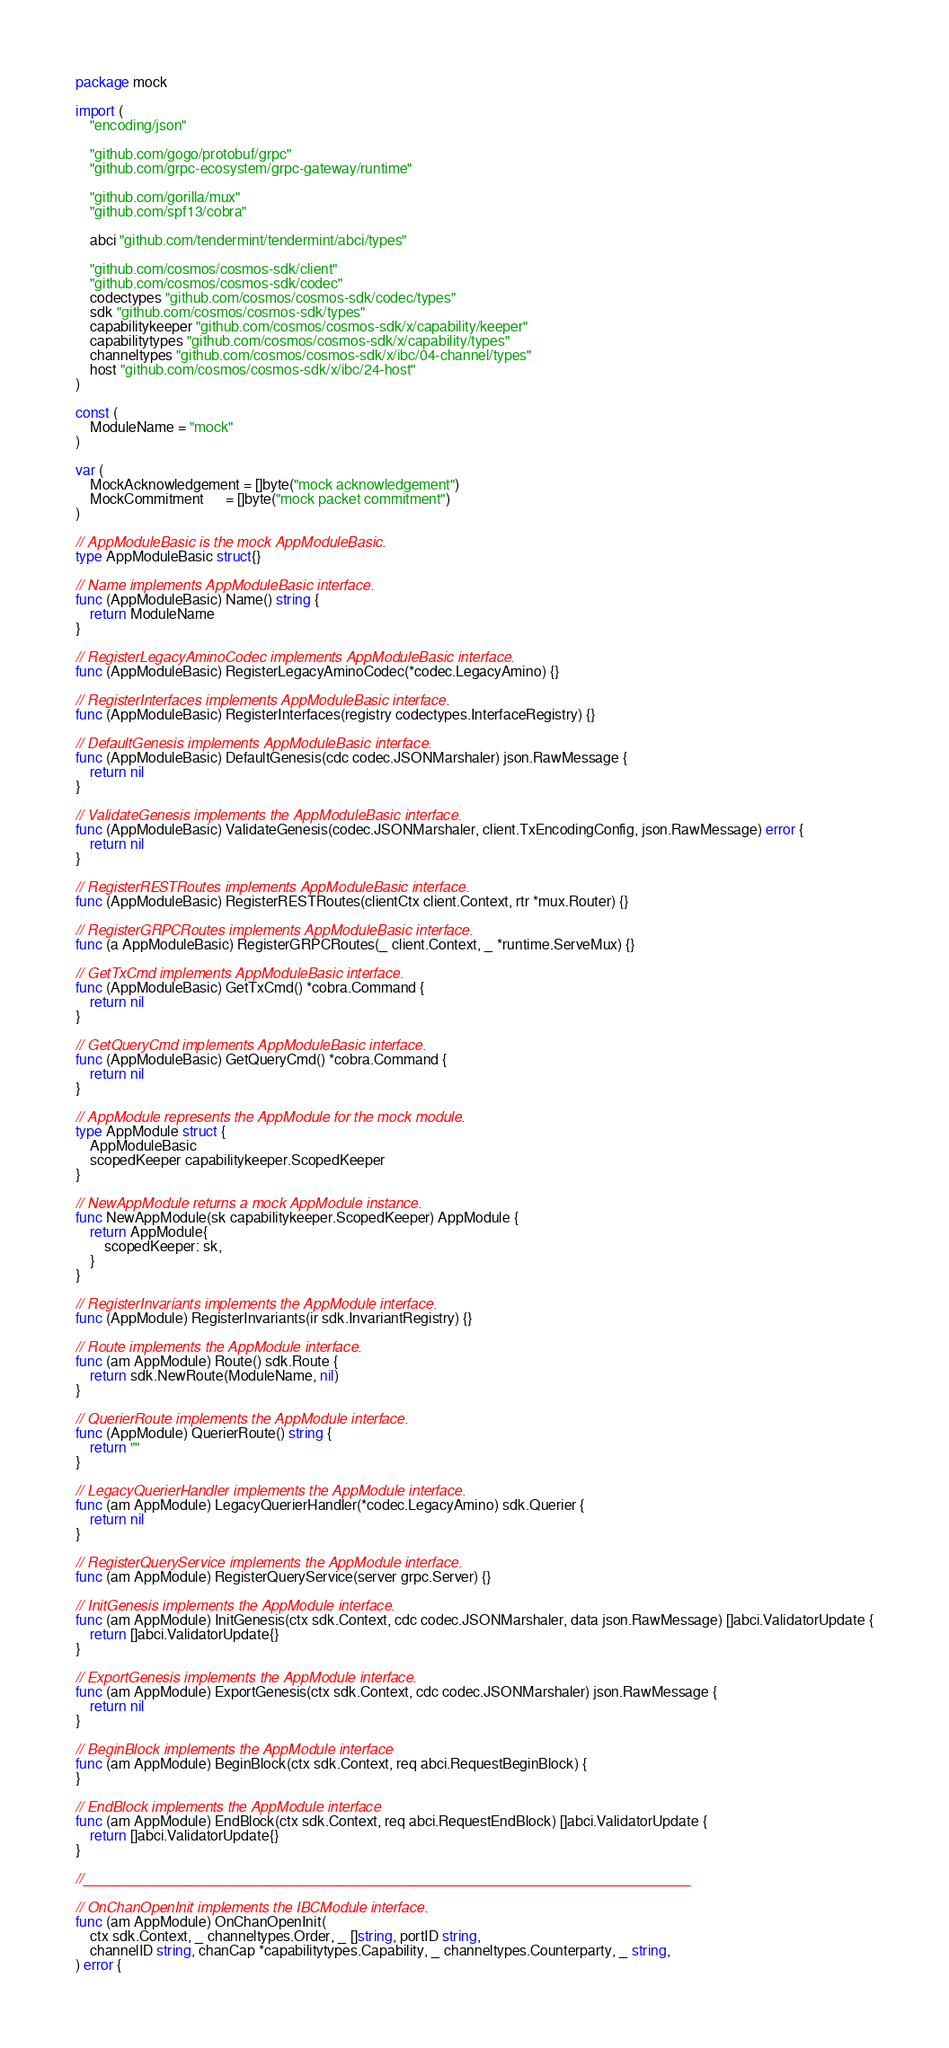Convert code to text. <code><loc_0><loc_0><loc_500><loc_500><_Go_>package mock

import (
	"encoding/json"

	"github.com/gogo/protobuf/grpc"
	"github.com/grpc-ecosystem/grpc-gateway/runtime"

	"github.com/gorilla/mux"
	"github.com/spf13/cobra"

	abci "github.com/tendermint/tendermint/abci/types"

	"github.com/cosmos/cosmos-sdk/client"
	"github.com/cosmos/cosmos-sdk/codec"
	codectypes "github.com/cosmos/cosmos-sdk/codec/types"
	sdk "github.com/cosmos/cosmos-sdk/types"
	capabilitykeeper "github.com/cosmos/cosmos-sdk/x/capability/keeper"
	capabilitytypes "github.com/cosmos/cosmos-sdk/x/capability/types"
	channeltypes "github.com/cosmos/cosmos-sdk/x/ibc/04-channel/types"
	host "github.com/cosmos/cosmos-sdk/x/ibc/24-host"
)

const (
	ModuleName = "mock"
)

var (
	MockAcknowledgement = []byte("mock acknowledgement")
	MockCommitment      = []byte("mock packet commitment")
)

// AppModuleBasic is the mock AppModuleBasic.
type AppModuleBasic struct{}

// Name implements AppModuleBasic interface.
func (AppModuleBasic) Name() string {
	return ModuleName
}

// RegisterLegacyAminoCodec implements AppModuleBasic interface.
func (AppModuleBasic) RegisterLegacyAminoCodec(*codec.LegacyAmino) {}

// RegisterInterfaces implements AppModuleBasic interface.
func (AppModuleBasic) RegisterInterfaces(registry codectypes.InterfaceRegistry) {}

// DefaultGenesis implements AppModuleBasic interface.
func (AppModuleBasic) DefaultGenesis(cdc codec.JSONMarshaler) json.RawMessage {
	return nil
}

// ValidateGenesis implements the AppModuleBasic interface.
func (AppModuleBasic) ValidateGenesis(codec.JSONMarshaler, client.TxEncodingConfig, json.RawMessage) error {
	return nil
}

// RegisterRESTRoutes implements AppModuleBasic interface.
func (AppModuleBasic) RegisterRESTRoutes(clientCtx client.Context, rtr *mux.Router) {}

// RegisterGRPCRoutes implements AppModuleBasic interface.
func (a AppModuleBasic) RegisterGRPCRoutes(_ client.Context, _ *runtime.ServeMux) {}

// GetTxCmd implements AppModuleBasic interface.
func (AppModuleBasic) GetTxCmd() *cobra.Command {
	return nil
}

// GetQueryCmd implements AppModuleBasic interface.
func (AppModuleBasic) GetQueryCmd() *cobra.Command {
	return nil
}

// AppModule represents the AppModule for the mock module.
type AppModule struct {
	AppModuleBasic
	scopedKeeper capabilitykeeper.ScopedKeeper
}

// NewAppModule returns a mock AppModule instance.
func NewAppModule(sk capabilitykeeper.ScopedKeeper) AppModule {
	return AppModule{
		scopedKeeper: sk,
	}
}

// RegisterInvariants implements the AppModule interface.
func (AppModule) RegisterInvariants(ir sdk.InvariantRegistry) {}

// Route implements the AppModule interface.
func (am AppModule) Route() sdk.Route {
	return sdk.NewRoute(ModuleName, nil)
}

// QuerierRoute implements the AppModule interface.
func (AppModule) QuerierRoute() string {
	return ""
}

// LegacyQuerierHandler implements the AppModule interface.
func (am AppModule) LegacyQuerierHandler(*codec.LegacyAmino) sdk.Querier {
	return nil
}

// RegisterQueryService implements the AppModule interface.
func (am AppModule) RegisterQueryService(server grpc.Server) {}

// InitGenesis implements the AppModule interface.
func (am AppModule) InitGenesis(ctx sdk.Context, cdc codec.JSONMarshaler, data json.RawMessage) []abci.ValidatorUpdate {
	return []abci.ValidatorUpdate{}
}

// ExportGenesis implements the AppModule interface.
func (am AppModule) ExportGenesis(ctx sdk.Context, cdc codec.JSONMarshaler) json.RawMessage {
	return nil
}

// BeginBlock implements the AppModule interface
func (am AppModule) BeginBlock(ctx sdk.Context, req abci.RequestBeginBlock) {
}

// EndBlock implements the AppModule interface
func (am AppModule) EndBlock(ctx sdk.Context, req abci.RequestEndBlock) []abci.ValidatorUpdate {
	return []abci.ValidatorUpdate{}
}

//____________________________________________________________________________

// OnChanOpenInit implements the IBCModule interface.
func (am AppModule) OnChanOpenInit(
	ctx sdk.Context, _ channeltypes.Order, _ []string, portID string,
	channelID string, chanCap *capabilitytypes.Capability, _ channeltypes.Counterparty, _ string,
) error {</code> 